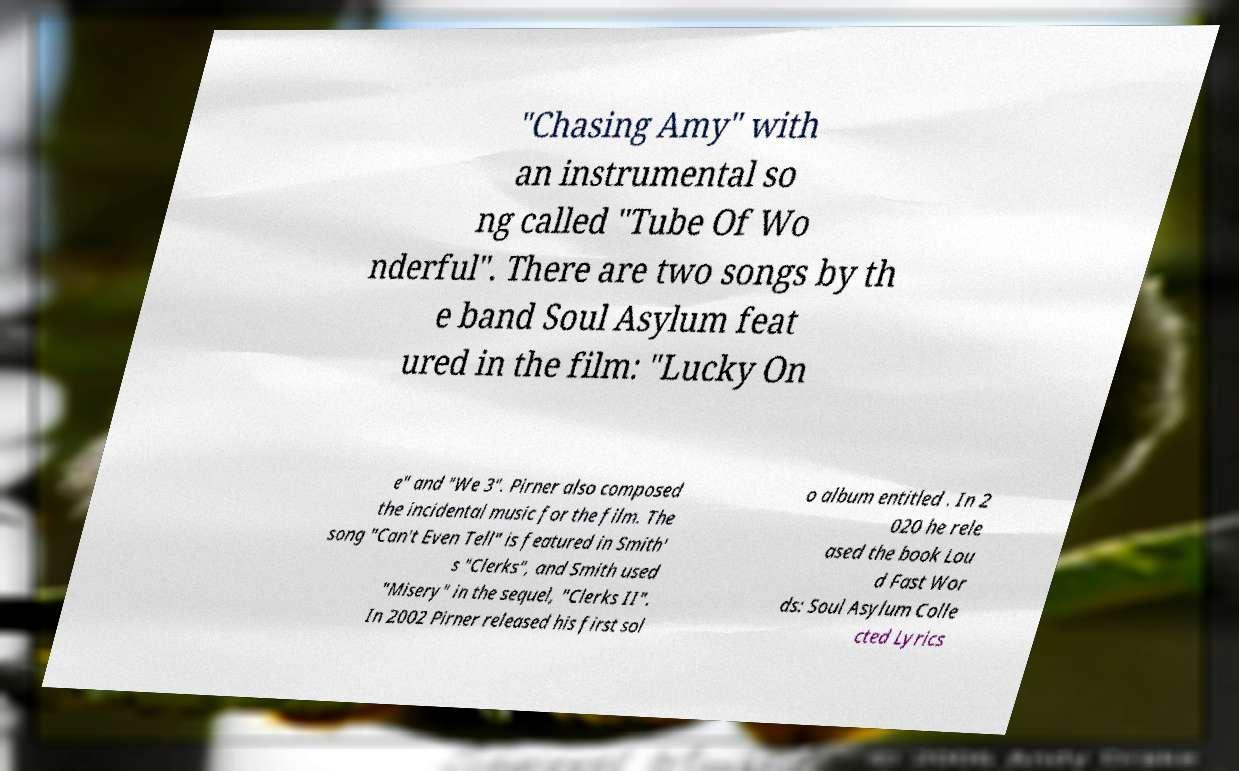Please identify and transcribe the text found in this image. "Chasing Amy" with an instrumental so ng called "Tube Of Wo nderful". There are two songs by th e band Soul Asylum feat ured in the film: "Lucky On e" and "We 3". Pirner also composed the incidental music for the film. The song "Can't Even Tell" is featured in Smith' s "Clerks", and Smith used "Misery" in the sequel, "Clerks II". In 2002 Pirner released his first sol o album entitled . In 2 020 he rele ased the book Lou d Fast Wor ds: Soul Asylum Colle cted Lyrics 